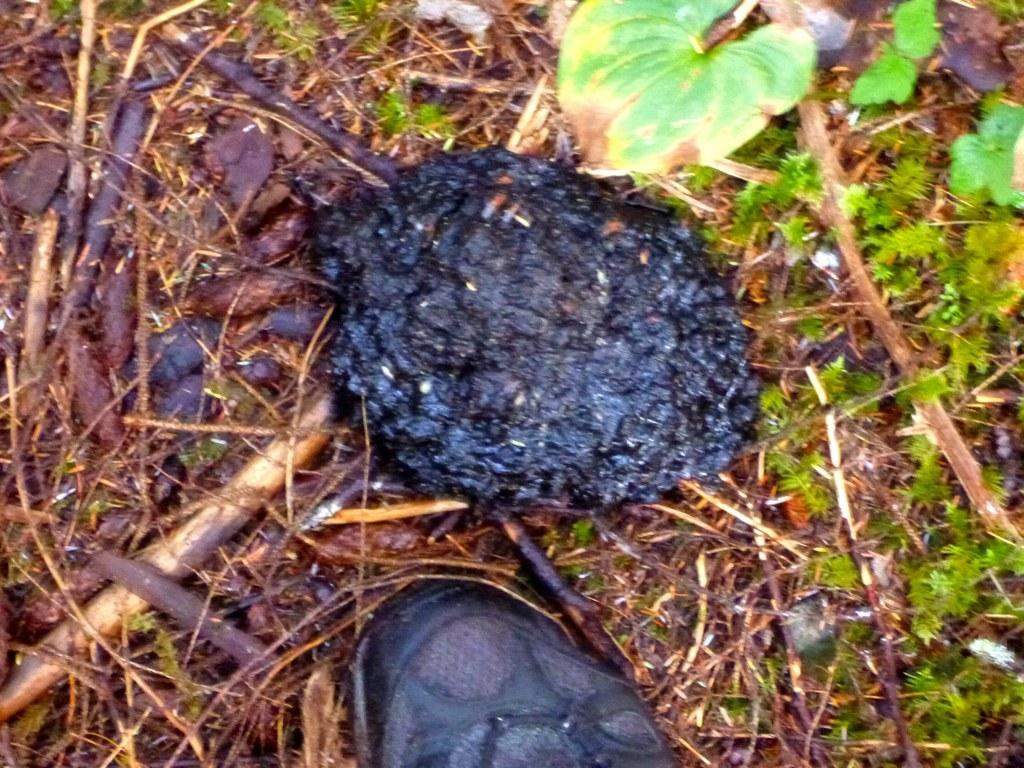What type of vegetation can be seen in the image? There is grass in the image. What else can be found in the image besides grass? There are leaves and animal dung in the image. Are there any man-made objects visible in the image? Yes, there are wooden pieces in the image. What type of comfort does the bear provide in the image? There is no bear present in the image, so it is not possible to answer that question. 